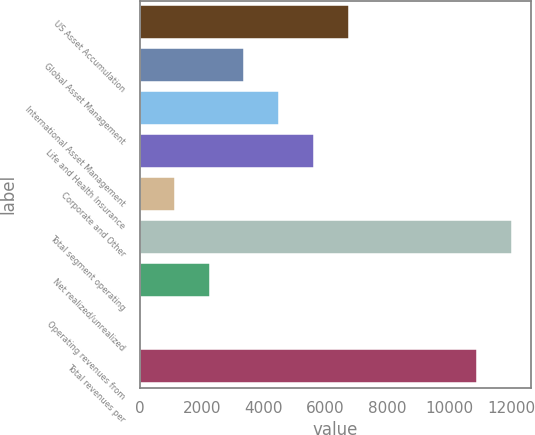<chart> <loc_0><loc_0><loc_500><loc_500><bar_chart><fcel>US Asset Accumulation<fcel>Global Asset Management<fcel>International Asset Management<fcel>Life and Health Insurance<fcel>Corporate and Other<fcel>Total segment operating<fcel>Net realized/unrealized<fcel>Operating revenues from<fcel>Total revenues per<nl><fcel>6750<fcel>3375.15<fcel>4500.1<fcel>5625.05<fcel>1125.25<fcel>12031.5<fcel>2250.2<fcel>0.3<fcel>10906.5<nl></chart> 